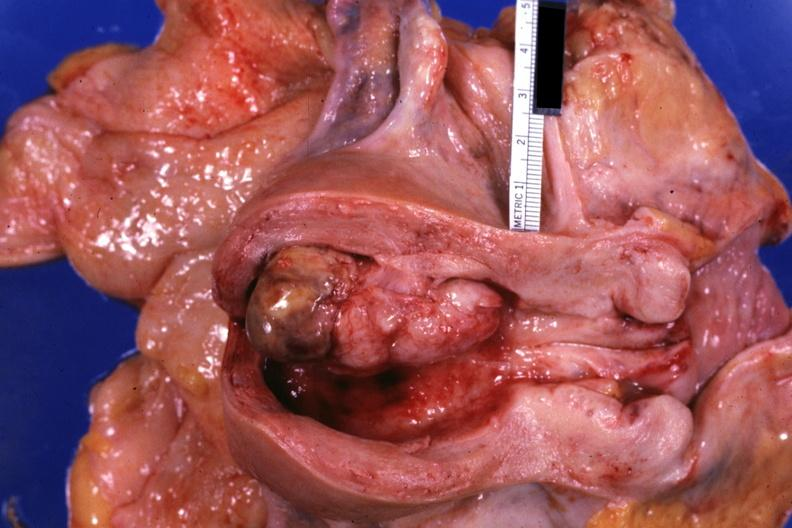s surface present?
Answer the question using a single word or phrase. No 